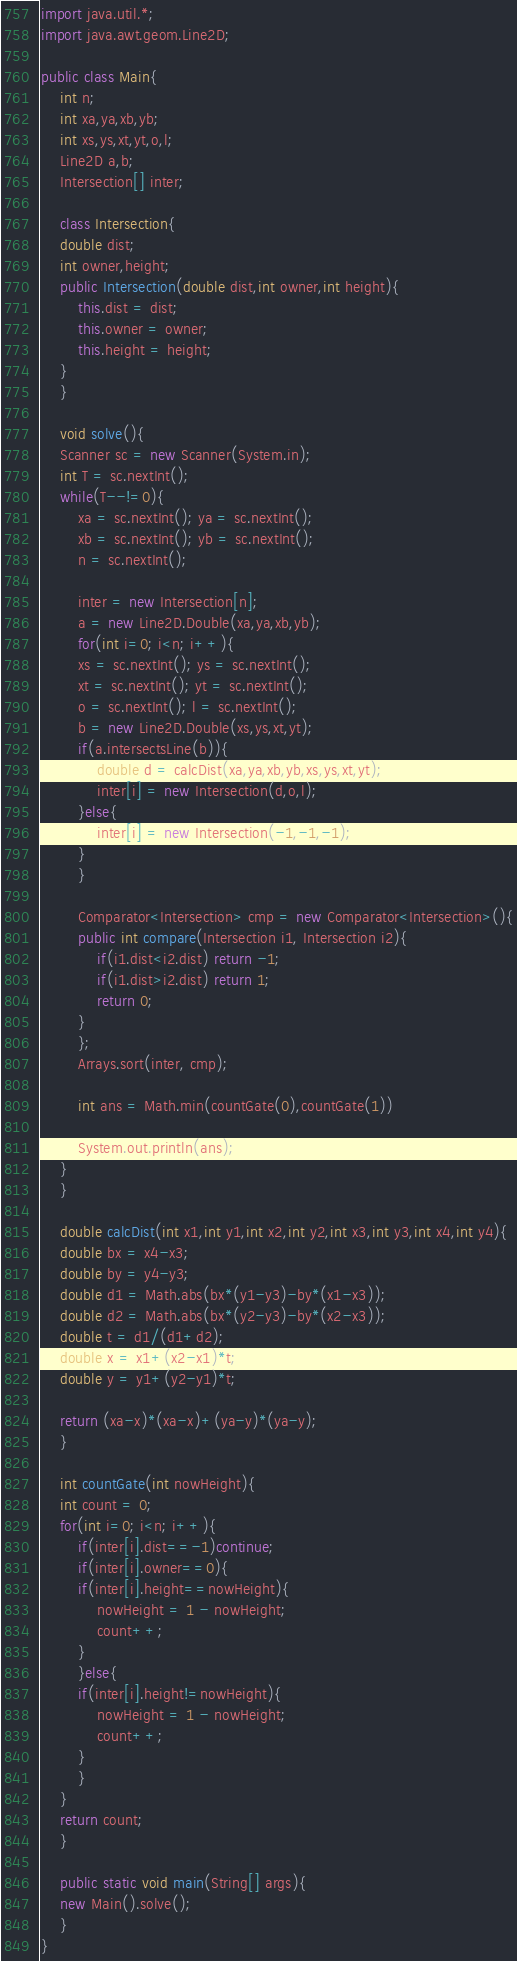<code> <loc_0><loc_0><loc_500><loc_500><_Java_>import java.util.*;
import java.awt.geom.Line2D;

public class Main{
    int n;
    int xa,ya,xb,yb;
    int xs,ys,xt,yt,o,l;
    Line2D a,b;
    Intersection[] inter;

    class Intersection{
	double dist;
	int owner,height;
	public Intersection(double dist,int owner,int height){
	    this.dist = dist;
	    this.owner = owner;
	    this.height = height;
	}
    }

    void solve(){
	Scanner sc = new Scanner(System.in);
	int T = sc.nextInt();
	while(T--!=0){
	    xa = sc.nextInt(); ya = sc.nextInt();
	    xb = sc.nextInt(); yb = sc.nextInt();
	    n = sc.nextInt();

	    inter = new Intersection[n];
	    a = new Line2D.Double(xa,ya,xb,yb);
	    for(int i=0; i<n; i++){
		xs = sc.nextInt(); ys = sc.nextInt();
		xt = sc.nextInt(); yt = sc.nextInt();
		o = sc.nextInt(); l = sc.nextInt();
		b = new Line2D.Double(xs,ys,xt,yt);
		if(a.intersectsLine(b)){
		    double d = calcDist(xa,ya,xb,yb,xs,ys,xt,yt);
		    inter[i] = new Intersection(d,o,l);
		}else{
		    inter[i] = new Intersection(-1,-1,-1);
		}
	    }

	    Comparator<Intersection> cmp = new Comparator<Intersection>(){
		public int compare(Intersection i1, Intersection i2){
		    if(i1.dist<i2.dist) return -1;
		    if(i1.dist>i2.dist) return 1;
		    return 0;
		}
	    };
	    Arrays.sort(inter, cmp);

	    int ans = Math.min(countGate(0),countGate(1))
	    
	    System.out.println(ans);
	}
    }
    
    double calcDist(int x1,int y1,int x2,int y2,int x3,int y3,int x4,int y4){
	double bx = x4-x3;
	double by = y4-y3;
	double d1 = Math.abs(bx*(y1-y3)-by*(x1-x3));
	double d2 = Math.abs(bx*(y2-y3)-by*(x2-x3));
	double t = d1/(d1+d2);	
	double x = x1+(x2-x1)*t;
	double y = y1+(y2-y1)*t;
	
	return (xa-x)*(xa-x)+(ya-y)*(ya-y);
    }
    
    int countGate(int nowHeight){
	int count = 0;
	for(int i=0; i<n; i++){
	    if(inter[i].dist==-1)continue;
	    if(inter[i].owner==0){
		if(inter[i].height==nowHeight){
		    nowHeight = 1 - nowHeight;
		    count++;
		}
	    }else{
		if(inter[i].height!=nowHeight){
		    nowHeight = 1 - nowHeight;
		    count++;
		}
	    }
	}
	return count;
    }
    
    public static void main(String[] args){
	new Main().solve();
    }
}</code> 